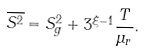<formula> <loc_0><loc_0><loc_500><loc_500>\overline { S ^ { 2 } } = S _ { g } ^ { 2 } + 3 ^ { \xi - 1 } \frac { T } { \mu _ { r } } .</formula> 